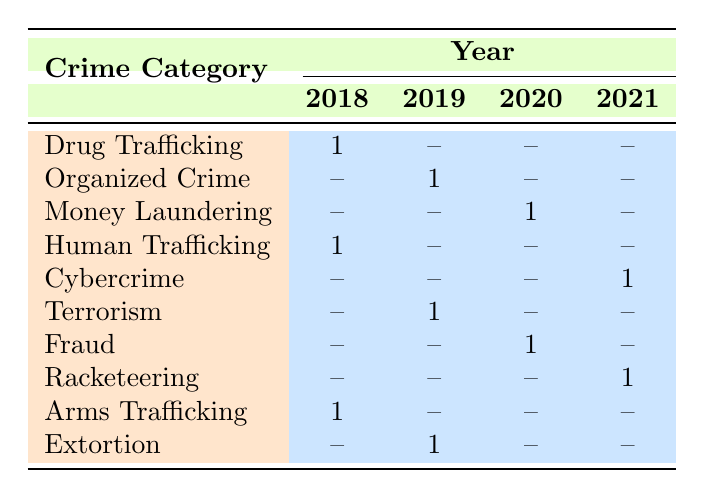What is the total number of successful prosecutions across all years? Counting the number of rows in the table represents distinct successful prosecutions. There are 10 rows total, indicating 10 successful prosecutions across all years.
Answer: 10 Which crime category had the highest number of successful prosecutions in a single year? Looking at the table, both Drug Trafficking and Human Trafficking had 1 successful prosecution in 2018, while the other categories have no more than 1 prosecution in any year. Hence, the maximum for a year in all categories is 1.
Answer: Drug Trafficking and Human Trafficking In which year was the crime of Terrorism prosecuted successfully? In the table, the row for Terrorism indicates a successful prosecution occurred in 2019.
Answer: 2019 How many defendants were involved in total for all successful prosecutions listed in the table? To find this, we sum up the "Number of Defendants" for each row: 3 (Drug Trafficking) + 5 (Organized Crime) + 2 (Money Laundering) + 4 (Human Trafficking) + 1 (Cybercrime) + 3 (Terrorism) + 2 (Fraud) + 6 (Racketeering) + 3 (Arms Trafficking) + 2 (Extortion) = 31 defendants.
Answer: 31 Was there a successful prosecution for Cybercrime? The table lists a successful prosecution row for Cybercrime in 2021, indicating that there was indeed a successful prosecution.
Answer: Yes What is the average sentence length for successful prosecutions in the year 2018? From the table, the sentence lengths for 2018 are 12 (Drug Trafficking), 15 (Human Trafficking), and 14 (Arms Trafficking). The average is calculated by summing these (12 + 15 + 14 = 41) and dividing by the number of prosecutions (3), yielding an average of 41 / 3 = 13.67.
Answer: 13.67 In which crime category was the maximum protection level assigned in successful prosecutions? By inspecting the table, the crime categories with "Maximum" protection level are Organized Crime (2019) and Terrorism (2019). Since both are listed, the answer is those two categories.
Answer: Organized Crime and Terrorism How many distinct crime categories have successful prosecutions in 2020? Referring to the table, the successful prosecutions in 2020 include Money Laundering and Fraud, which indicates that there are 2 distinct categories for that year.
Answer: 2 Was there no successful prosecution for the crime of Extortion in 2020? The table shows that there is no entry for Extortion in 2020, confirming that no successful prosecution occurred for that crime in that year.
Answer: Yes 